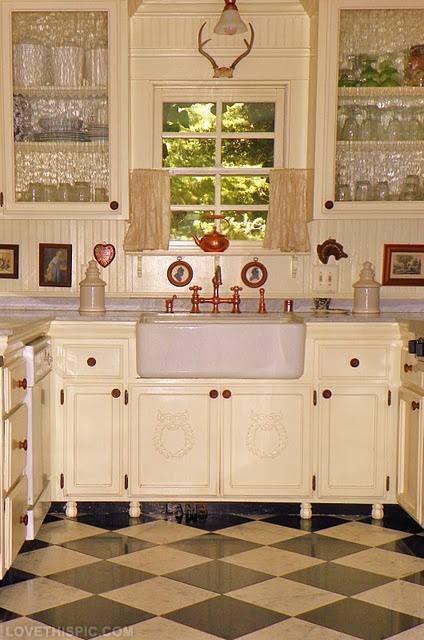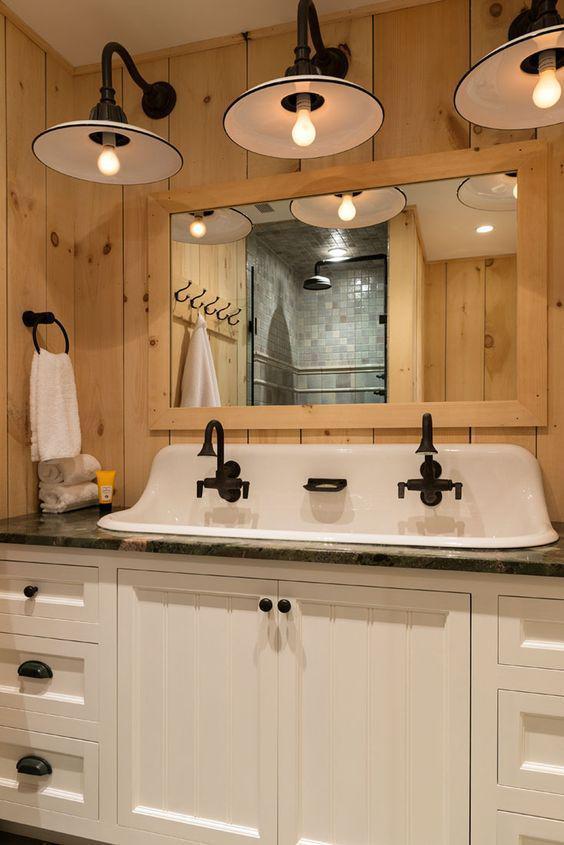The first image is the image on the left, the second image is the image on the right. Given the left and right images, does the statement "A row of three saucer shape lights are suspended above a mirror and sink." hold true? Answer yes or no. Yes. The first image is the image on the left, the second image is the image on the right. Given the left and right images, does the statement "At least two rolls of toilet paper are in a container and near a sink." hold true? Answer yes or no. No. 